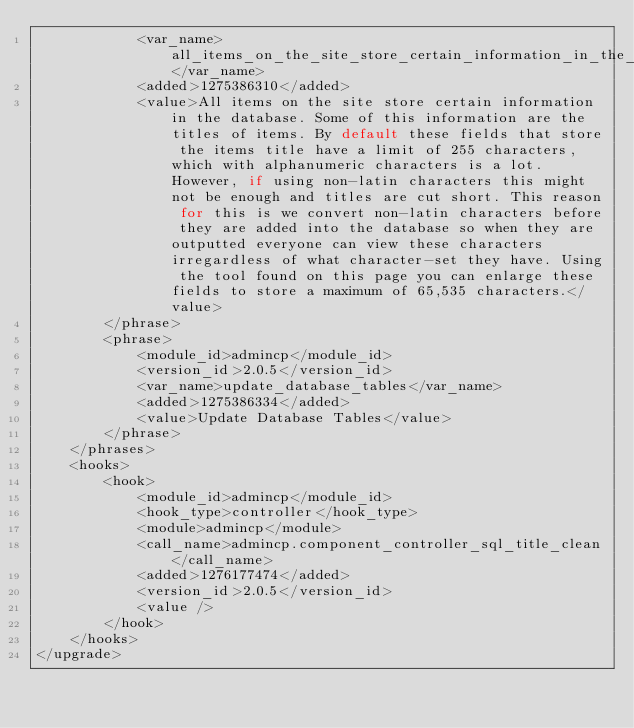<code> <loc_0><loc_0><loc_500><loc_500><_PHP_>			<var_name>all_items_on_the_site_store_certain_information_in_the_database</var_name>
			<added>1275386310</added>
			<value>All items on the site store certain information in the database. Some of this information are the titles of items. By default these fields that store the items title have a limit of 255 characters, which with alphanumeric characters is a lot. However, if using non-latin characters this might not be enough and titles are cut short. This reason for this is we convert non-latin characters before they are added into the database so when they are outputted everyone can view these characters irregardless of what character-set they have. Using the tool found on this page you can enlarge these fields to store a maximum of 65,535 characters.</value>
		</phrase>
		<phrase>
			<module_id>admincp</module_id>
			<version_id>2.0.5</version_id>
			<var_name>update_database_tables</var_name>
			<added>1275386334</added>
			<value>Update Database Tables</value>
		</phrase>
	</phrases>
	<hooks>
		<hook>
			<module_id>admincp</module_id>
			<hook_type>controller</hook_type>
			<module>admincp</module>
			<call_name>admincp.component_controller_sql_title_clean</call_name>
			<added>1276177474</added>
			<version_id>2.0.5</version_id>
			<value />
		</hook>
	</hooks>
</upgrade></code> 